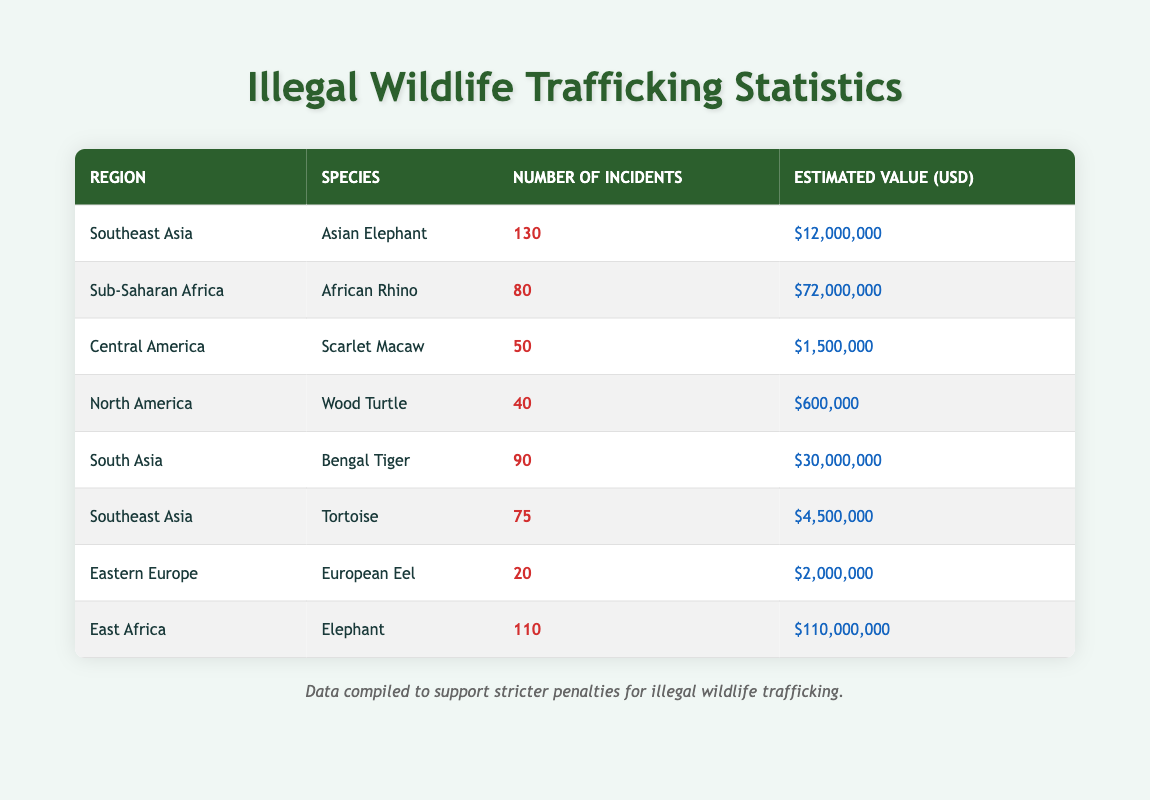What is the total number of incidents for illegal wildlife trafficking of the Asian Elephant? The table shows 130 incidents for the Asian Elephant in the Southeast Asia region.
Answer: 130 Which region has the highest estimated value of wildlife trafficking incidents? The highest estimated value in the table is 110,000,000 USD for the East Africa region involving Elephants.
Answer: East Africa How many more incidents are reported for the Bengal Tiger compared to the Scarlet Macaw? The Bengal Tiger has 90 incidents and the Scarlet Macaw has 50 incidents. The difference is 90 - 50 = 40.
Answer: 40 Is there at least one species listed with fewer than 50 incidents? The Wood Turtle has 40 incidents, which is fewer than 50, confirming that there is at least one such species.
Answer: Yes What is the average estimated value of incidents involving Tortoises in Southeast Asia? The table indicates that Tortoises have an estimated value of 4,500,000 USD and involve 75 incidents. Thus, average is 4,500,000 / 75 = 60,000 USD per incident.
Answer: 60,000 How many incidents are there in total for Southeast Asia and South Asia combined? Southeast Asia has 130 (Asian Elephant) + 75 (Tortoise) = 205 incidents and South Asia has 90 incidents for the Bengal Tiger. Thus, combined total is 205 + 90 = 295 incidents.
Answer: 295 Which species has the second highest estimated value for illegal wildlife trafficking? The second highest estimated value is for the African Rhino in Sub-Saharan Africa, which stands at 72,000,000 USD.
Answer: African Rhino Is it true that the European Eel is involved in more incidents than the Wood Turtle? The European Eel has 20 incidents, while the Wood Turtle has 40 incidents, making the statement false.
Answer: No What is the total estimated value of all incidents reported for wildlife trafficking in Central America? The Scarlet Macaw in Central America has an estimated value of 1,500,000 USD, and there are no other entries for this region, so the total estimated value remains 1,500,000 USD.
Answer: 1,500,000 